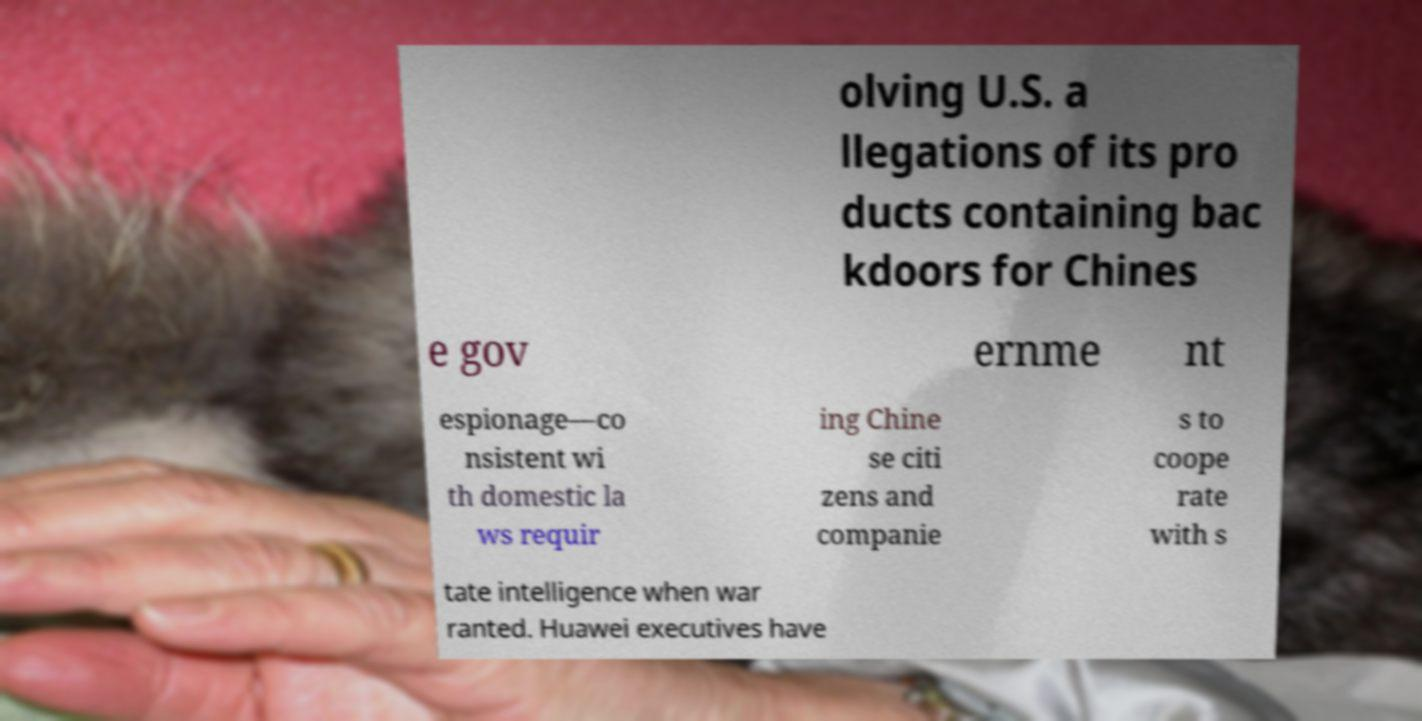Could you extract and type out the text from this image? olving U.S. a llegations of its pro ducts containing bac kdoors for Chines e gov ernme nt espionage—co nsistent wi th domestic la ws requir ing Chine se citi zens and companie s to coope rate with s tate intelligence when war ranted. Huawei executives have 